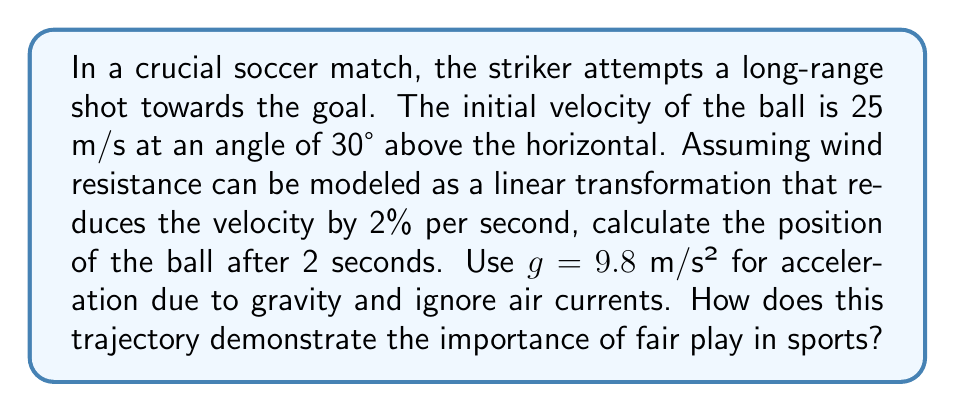Can you answer this question? To solve this problem, we'll use linear transformations to model the ball's trajectory while considering wind resistance. Let's break it down step-by-step:

1. Initial velocity components:
   $v_x = 25 \cos(30°) = 21.65$ m/s
   $v_y = 25 \sin(30°) = 12.5$ m/s

2. Wind resistance transformation matrix:
   The wind resistance reduces velocity by 2% per second, so after 2 seconds, the velocity is reduced by 4%.
   $$T_w = \begin{bmatrix} 0.96 & 0 \\ 0 & 0.96 \end{bmatrix}$$

3. Gravity transformation:
   The effect of gravity on velocity after 2 seconds:
   $$\Delta v_y = -gt = -9.8 \cdot 2 = -19.6$$ m/s

4. Final velocity:
   $$\begin{bmatrix} v_x' \\ v_y' \end{bmatrix} = T_w \begin{bmatrix} v_x \\ v_y \end{bmatrix} + \begin{bmatrix} 0 \\ \Delta v_y \end{bmatrix}$$
   $$\begin{bmatrix} v_x' \\ v_y' \end{bmatrix} = \begin{bmatrix} 0.96 & 0 \\ 0 & 0.96 \end{bmatrix} \begin{bmatrix} 21.65 \\ 12.5 \end{bmatrix} + \begin{bmatrix} 0 \\ -19.6 \end{bmatrix}$$
   $$\begin{bmatrix} v_x' \\ v_y' \end{bmatrix} = \begin{bmatrix} 20.78 \\ -7.6 \end{bmatrix}$$

5. Position after 2 seconds:
   $$\begin{bmatrix} x \\ y \end{bmatrix} = \begin{bmatrix} v_x \cdot t \\ v_y \cdot t - \frac{1}{2}gt^2 \end{bmatrix}$$
   $$\begin{bmatrix} x \\ y \end{bmatrix} = \begin{bmatrix} 21.65 \cdot 2 \\ 12.5 \cdot 2 - \frac{1}{2} \cdot 9.8 \cdot 2^2 \end{bmatrix}$$
   $$\begin{bmatrix} x \\ y \end{bmatrix} = \begin{bmatrix} 43.3 \\ 5.4 \end{bmatrix}$$

This trajectory demonstrates the importance of fair play in sports by showing how precise calculations and adherence to physical laws govern the ball's movement. Just as players must follow the rules, the ball follows the laws of physics. Any attempt to unfairly influence the ball's trajectory (e.g., using an illegal ball or tampering with equipment) would disrupt this natural path, emphasizing the need for integrity and fair competition in sports.
Answer: The position of the ball after 2 seconds is approximately (43.3 m, 5.4 m). 